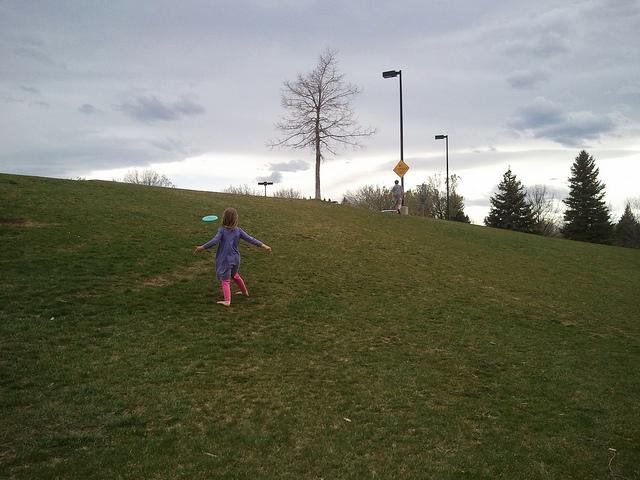What happened here?
Be succinct. Frisbee thrown. How many people do you see?
Quick response, please. 2. Who will end up with the Frisbee?
Answer briefly. Girl. What type of shoes is she wearing?
Quick response, please. None. What season is this?
Keep it brief. Fall. What color is the sign?
Quick response, please. Yellow. Is there water in this picture?
Short answer required. No. What is the girl playing with?
Write a very short answer. Frisbee. Is this a current generation photo?
Quick response, please. Yes. Is the girl throwing the frisbee to someone?
Be succinct. No. 